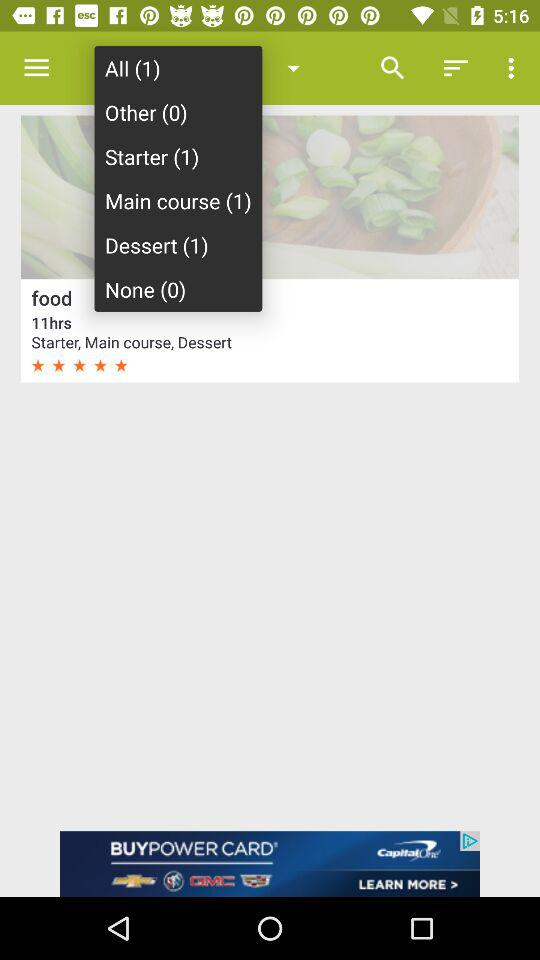How many types of foods are in the main course? The type of food in the main course is 1. 